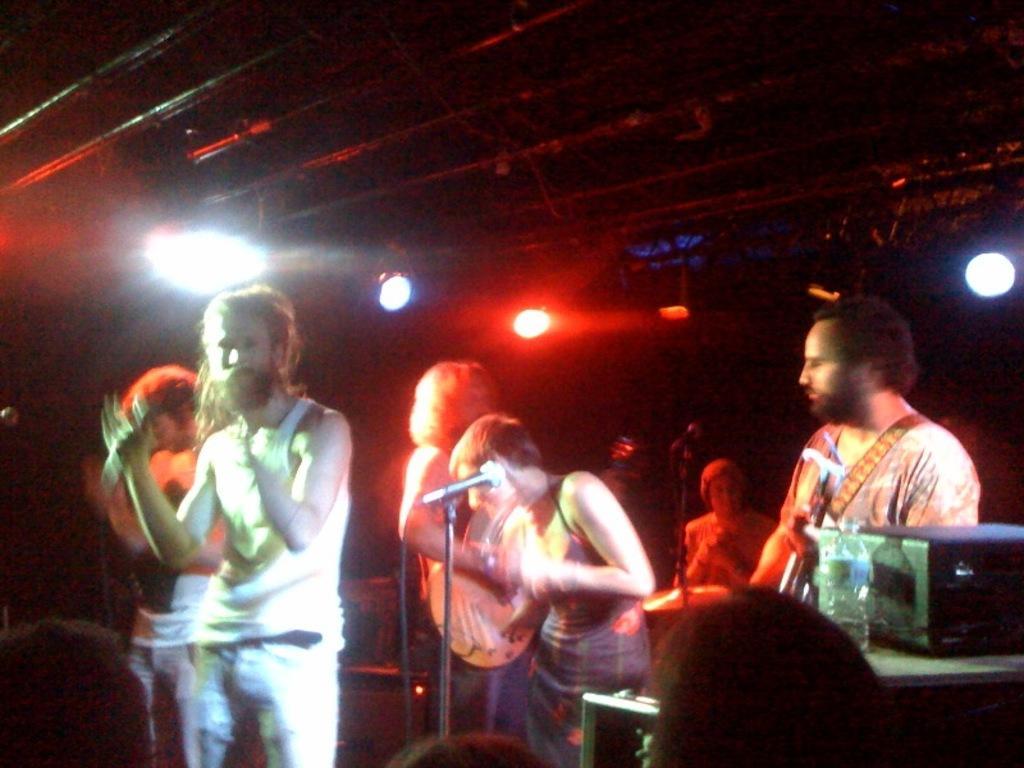Describe this image in one or two sentences. In the left there is a man ,he is wearing a trouser. In the middle there is a woman she is wearing a dress. To the right there is a man he is holding some musical instrument. To the right there is a table on that table ,there is a bottle and some other items. In the background there are some people. I think this is a stage performance. In the background there are many focus lights. 